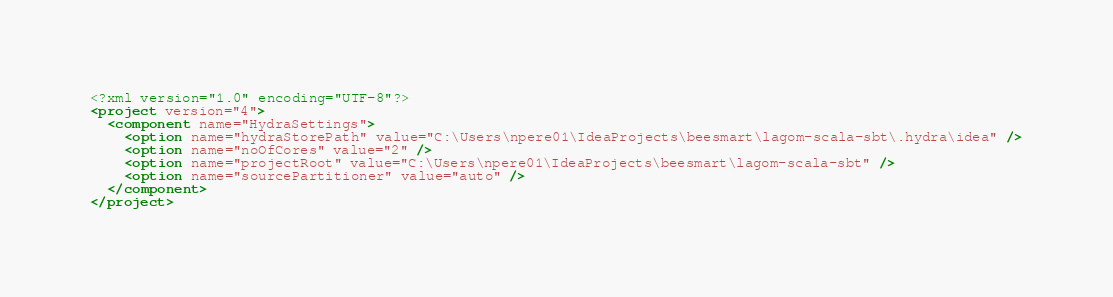<code> <loc_0><loc_0><loc_500><loc_500><_XML_><?xml version="1.0" encoding="UTF-8"?>
<project version="4">
  <component name="HydraSettings">
    <option name="hydraStorePath" value="C:\Users\npere01\IdeaProjects\beesmart\lagom-scala-sbt\.hydra\idea" />
    <option name="noOfCores" value="2" />
    <option name="projectRoot" value="C:\Users\npere01\IdeaProjects\beesmart\lagom-scala-sbt" />
    <option name="sourcePartitioner" value="auto" />
  </component>
</project></code> 